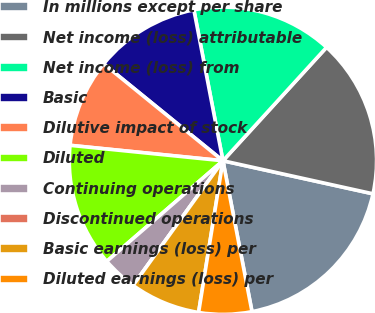<chart> <loc_0><loc_0><loc_500><loc_500><pie_chart><fcel>In millions except per share<fcel>Net income (loss) attributable<fcel>Net income (loss) from<fcel>Basic<fcel>Dilutive impact of stock<fcel>Diluted<fcel>Continuing operations<fcel>Discontinued operations<fcel>Basic earnings (loss) per<fcel>Diluted earnings (loss) per<nl><fcel>18.52%<fcel>16.67%<fcel>14.81%<fcel>11.11%<fcel>9.26%<fcel>12.96%<fcel>3.7%<fcel>0.0%<fcel>7.41%<fcel>5.56%<nl></chart> 